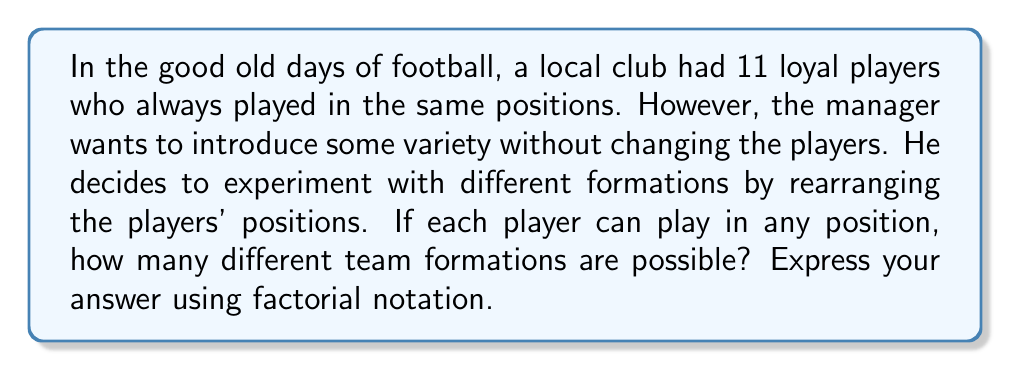Show me your answer to this math problem. Let's approach this problem using group theory concepts:

1) We have 11 players, and each formation is a unique arrangement of these players in 11 positions.

2) In group theory, this scenario is equivalent to finding the number of permutations of 11 distinct elements.

3) The set of all permutations of n distinct elements forms a symmetric group, denoted as $S_n$.

4) The order (size) of the symmetric group $S_n$ is given by $n!$ (n factorial).

5) In this case, we have 11 players, so we're dealing with $S_{11}$.

6) Therefore, the number of possible team formations is equal to the order of $S_{11}$, which is $11!$.

7) To understand why this works:
   - The first player has 11 choices for position
   - The second player then has 10 choices
   - The third player has 9 choices, and so on...

8) This gives us the multiplication: $11 \times 10 \times 9 \times 8 \times 7 \times 6 \times 5 \times 4 \times 3 \times 2 \times 1 = 11!$

9) $11! = 39,916,800$, which is a very large number of possible formations!

This demonstrates why loyalty and consistent positioning were so valued in traditional football - the sheer number of possible arrangements could be overwhelming without a stable, familiar formation.
Answer: $11!$ or 39,916,800 possible team formations 